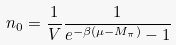<formula> <loc_0><loc_0><loc_500><loc_500>n _ { 0 } = \frac { 1 } { V } \frac { 1 } { e ^ { - \beta ( \mu - M _ { \pi } ) } - 1 }</formula> 